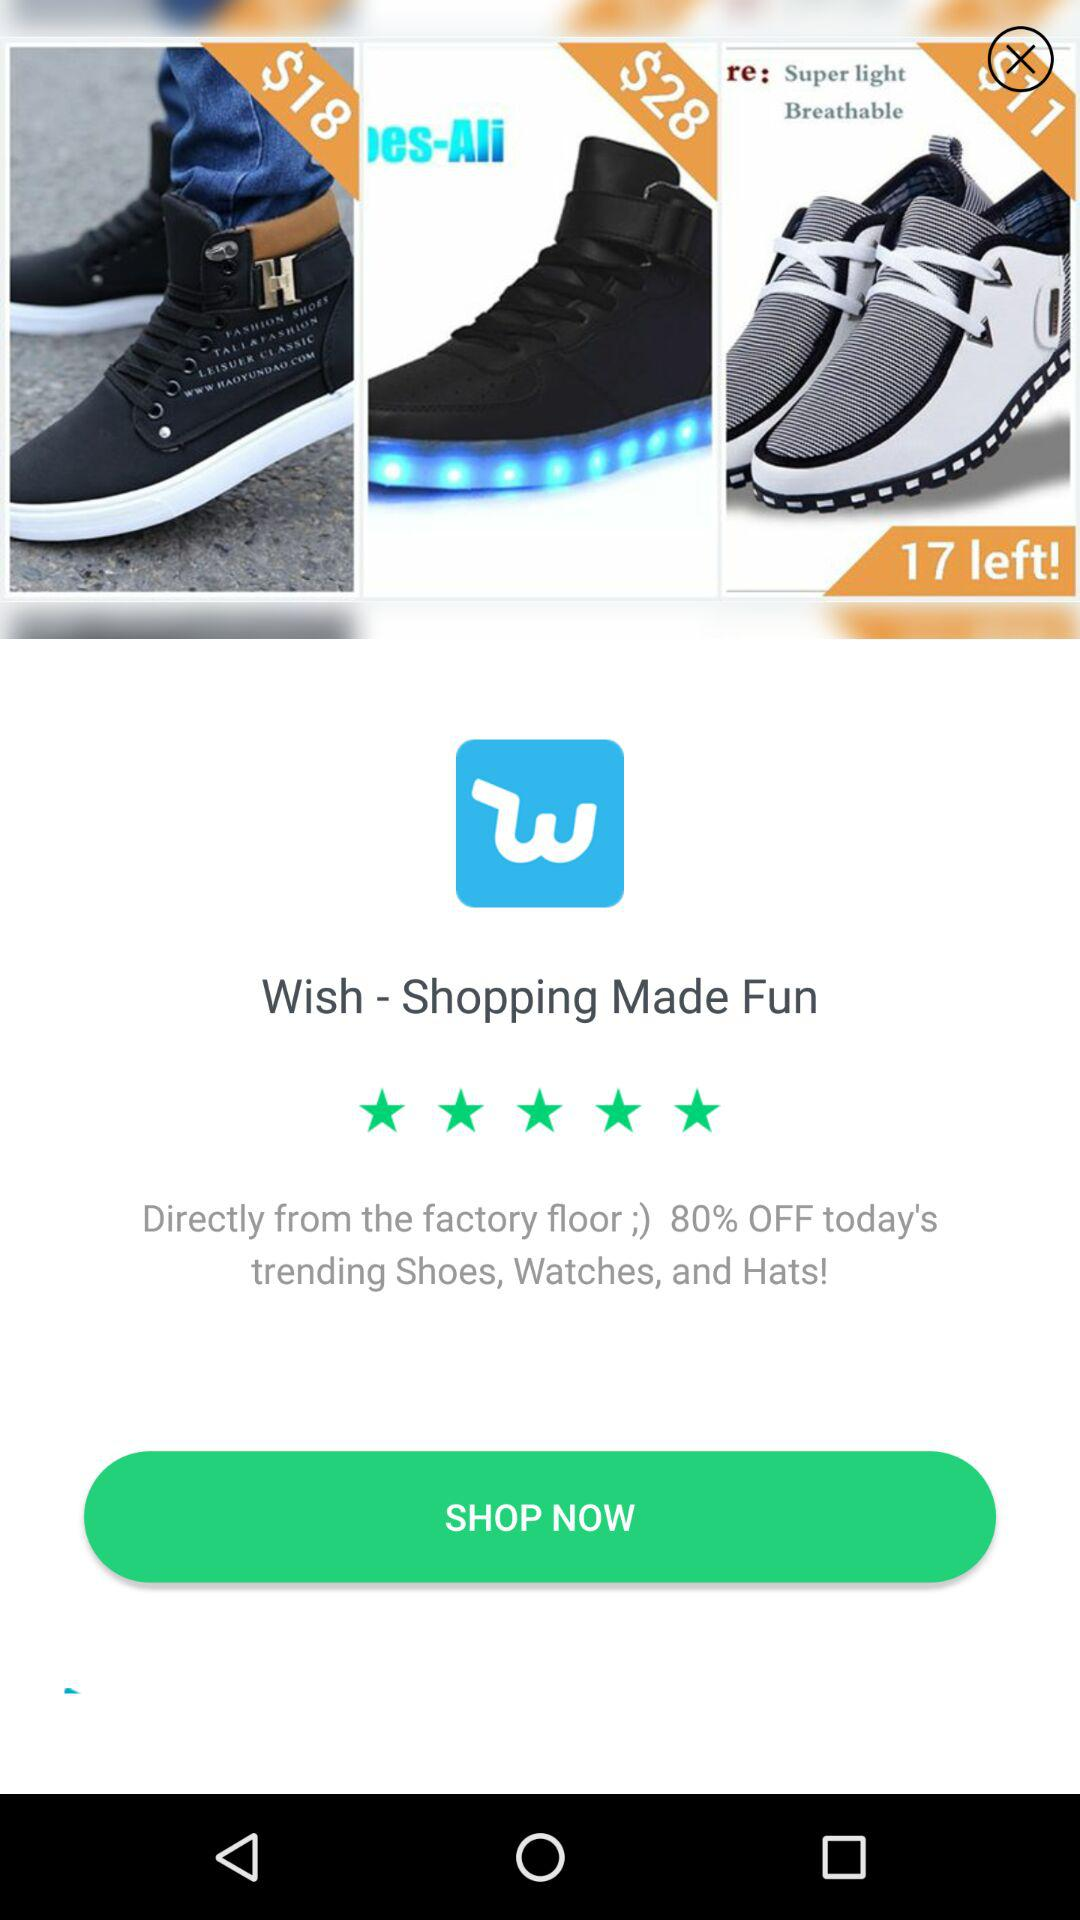How much more is the second item than the first?
Answer the question using a single word or phrase. $10 